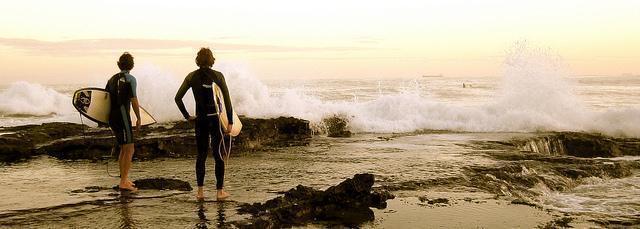Why are the surfer's hesitant to surf here?
Answer the question by selecting the correct answer among the 4 following choices.
Options: Huge waves, rocks, small waves, cold water. Rocks. 